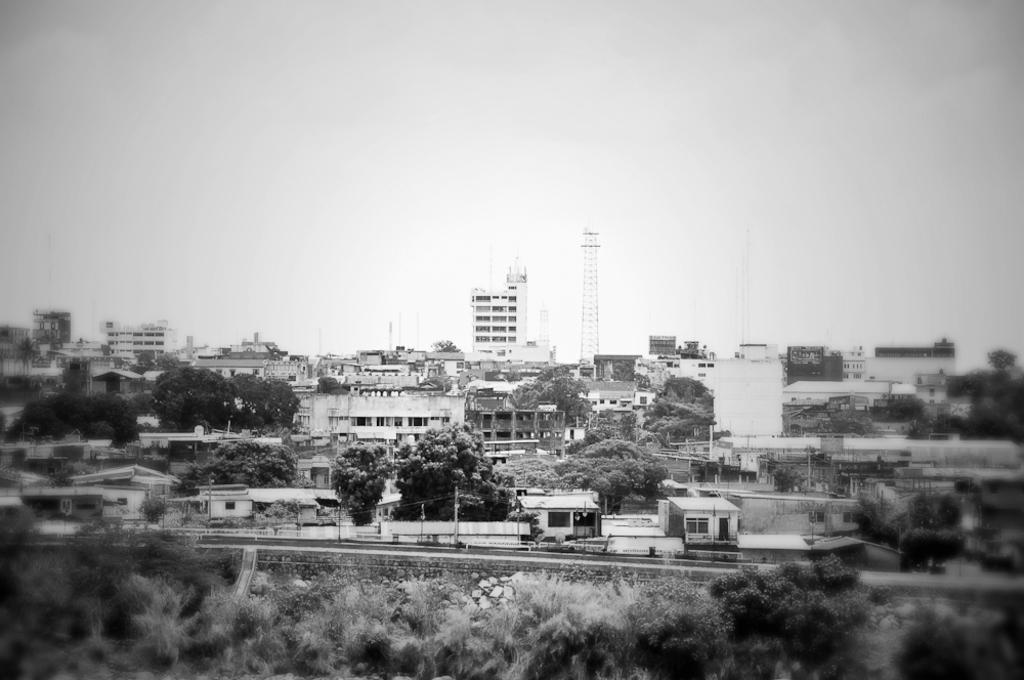Describe this image in one or two sentences. In this picture I can observe buildings and trees. There is a tower in the middle of this picture. In the background there is a sky. This is a black and white image. 